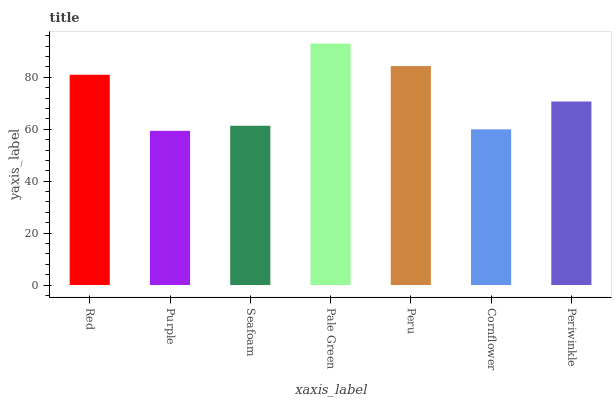Is Seafoam the minimum?
Answer yes or no. No. Is Seafoam the maximum?
Answer yes or no. No. Is Seafoam greater than Purple?
Answer yes or no. Yes. Is Purple less than Seafoam?
Answer yes or no. Yes. Is Purple greater than Seafoam?
Answer yes or no. No. Is Seafoam less than Purple?
Answer yes or no. No. Is Periwinkle the high median?
Answer yes or no. Yes. Is Periwinkle the low median?
Answer yes or no. Yes. Is Cornflower the high median?
Answer yes or no. No. Is Seafoam the low median?
Answer yes or no. No. 